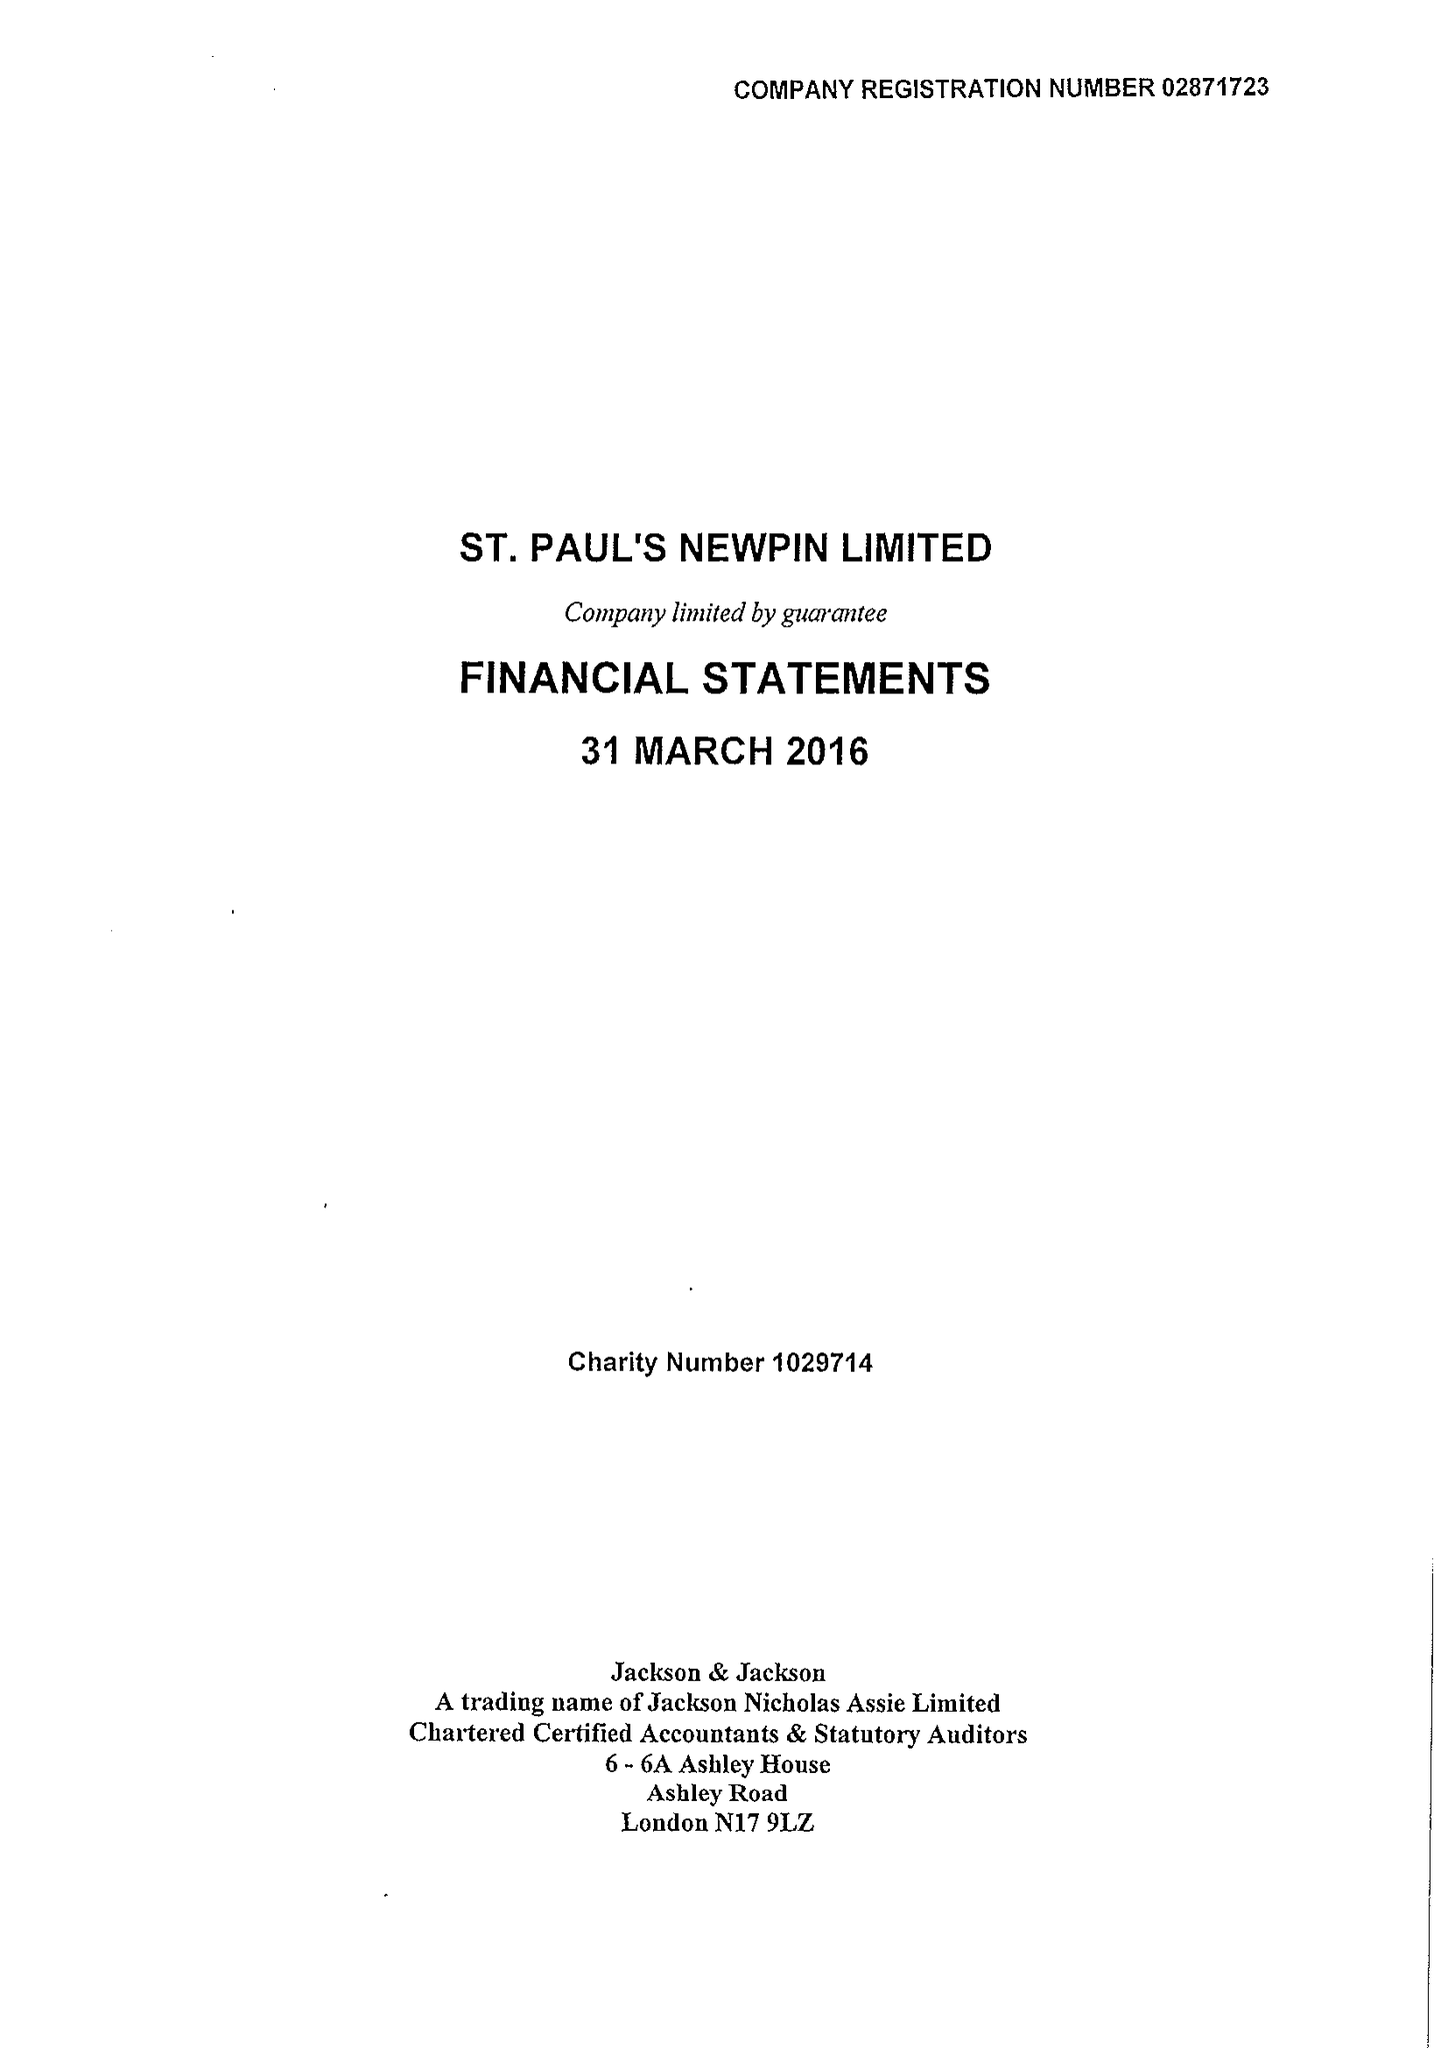What is the value for the address__post_town?
Answer the question using a single word or phrase. LONDON 